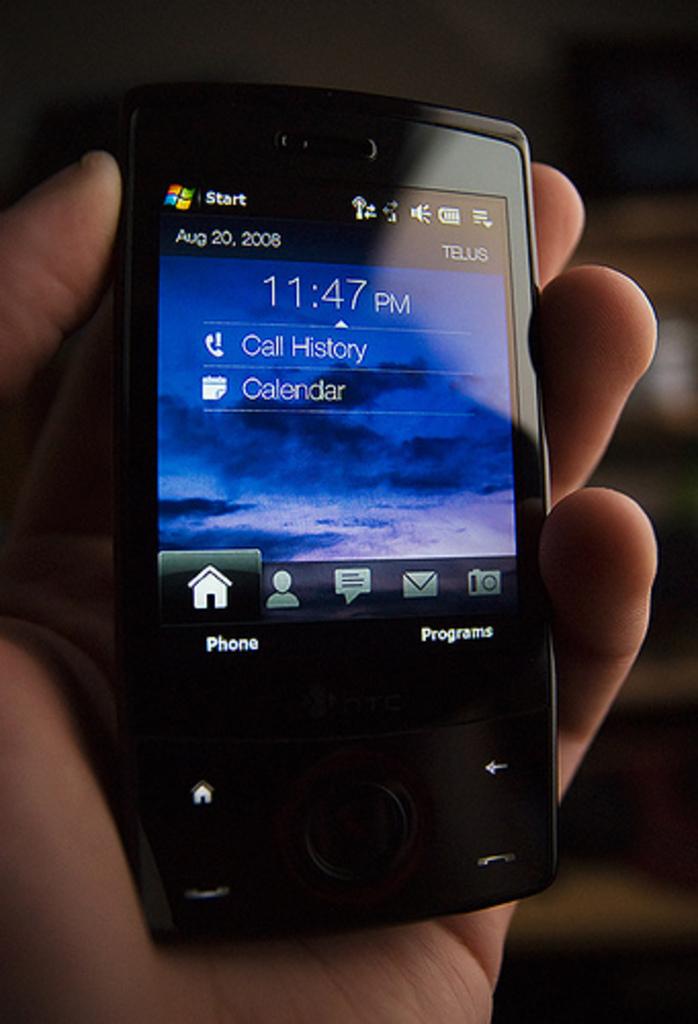What time is on the phone?
Give a very brief answer. 11:47 pm. 